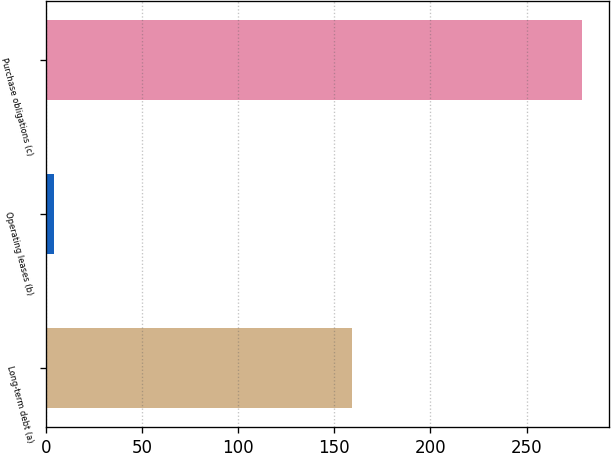Convert chart to OTSL. <chart><loc_0><loc_0><loc_500><loc_500><bar_chart><fcel>Long-term debt (a)<fcel>Operating leases (b)<fcel>Purchase obligations (c)<nl><fcel>159<fcel>4<fcel>279<nl></chart> 